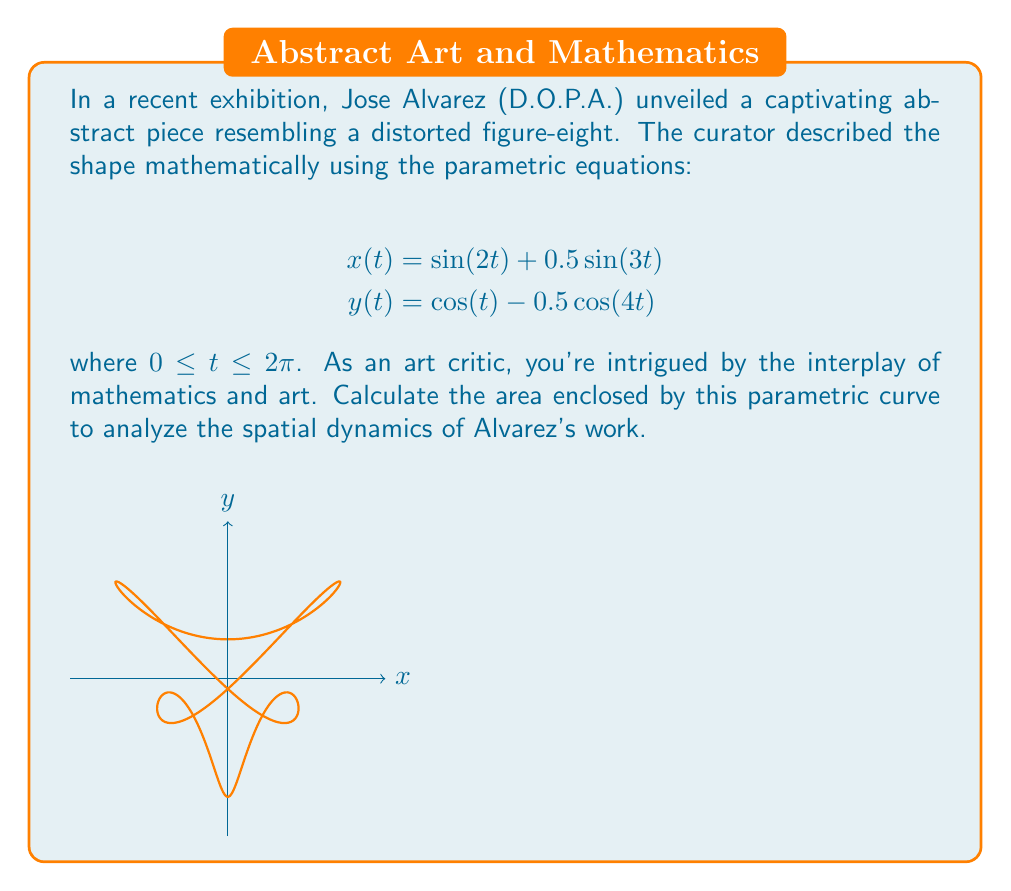Show me your answer to this math problem. To calculate the area enclosed by this parametric curve, we'll use Green's theorem in the form:

$$\text{Area} = \frac{1}{2} \int_0^{2\pi} [x(t)y'(t) - y(t)x'(t)] dt$$

Step 1: Calculate $x'(t)$ and $y'(t)$
$$x'(t) = 2\cos(2t) + 1.5\cos(3t)$$
$$y'(t) = -\sin(t) + 2\sin(4t)$$

Step 2: Substitute the expressions into the integrand
$$x(t)y'(t) - y(t)x'(t) = [\sin(2t) + 0.5\sin(3t)][-\sin(t) + 2\sin(4t)] - [\cos(t) - 0.5\cos(4t)][2\cos(2t) + 1.5\cos(3t)]$$

Step 3: Expand the integrand (this will be a long expression with many trigonometric terms)

Step 4: Integrate from 0 to $2\pi$
Most terms will integrate to zero over this interval. The non-zero terms are:

$$\frac{1}{2} \int_0^{2\pi} [-\frac{1}{2}\sin(2t)\sin(t) - \cos(t)(2\cos(2t))] dt$$

Step 5: Evaluate the integral
$$\text{Area} = \frac{1}{2} \cdot 2\pi \cdot (-\frac{1}{4} - 1) = -\frac{5\pi}{4}$$

Step 6: Take the absolute value for the final area
$$\text{Area} = |\frac{5\pi}{4}| = \frac{5\pi}{4}$$
Answer: $\frac{5\pi}{4}$ square units 